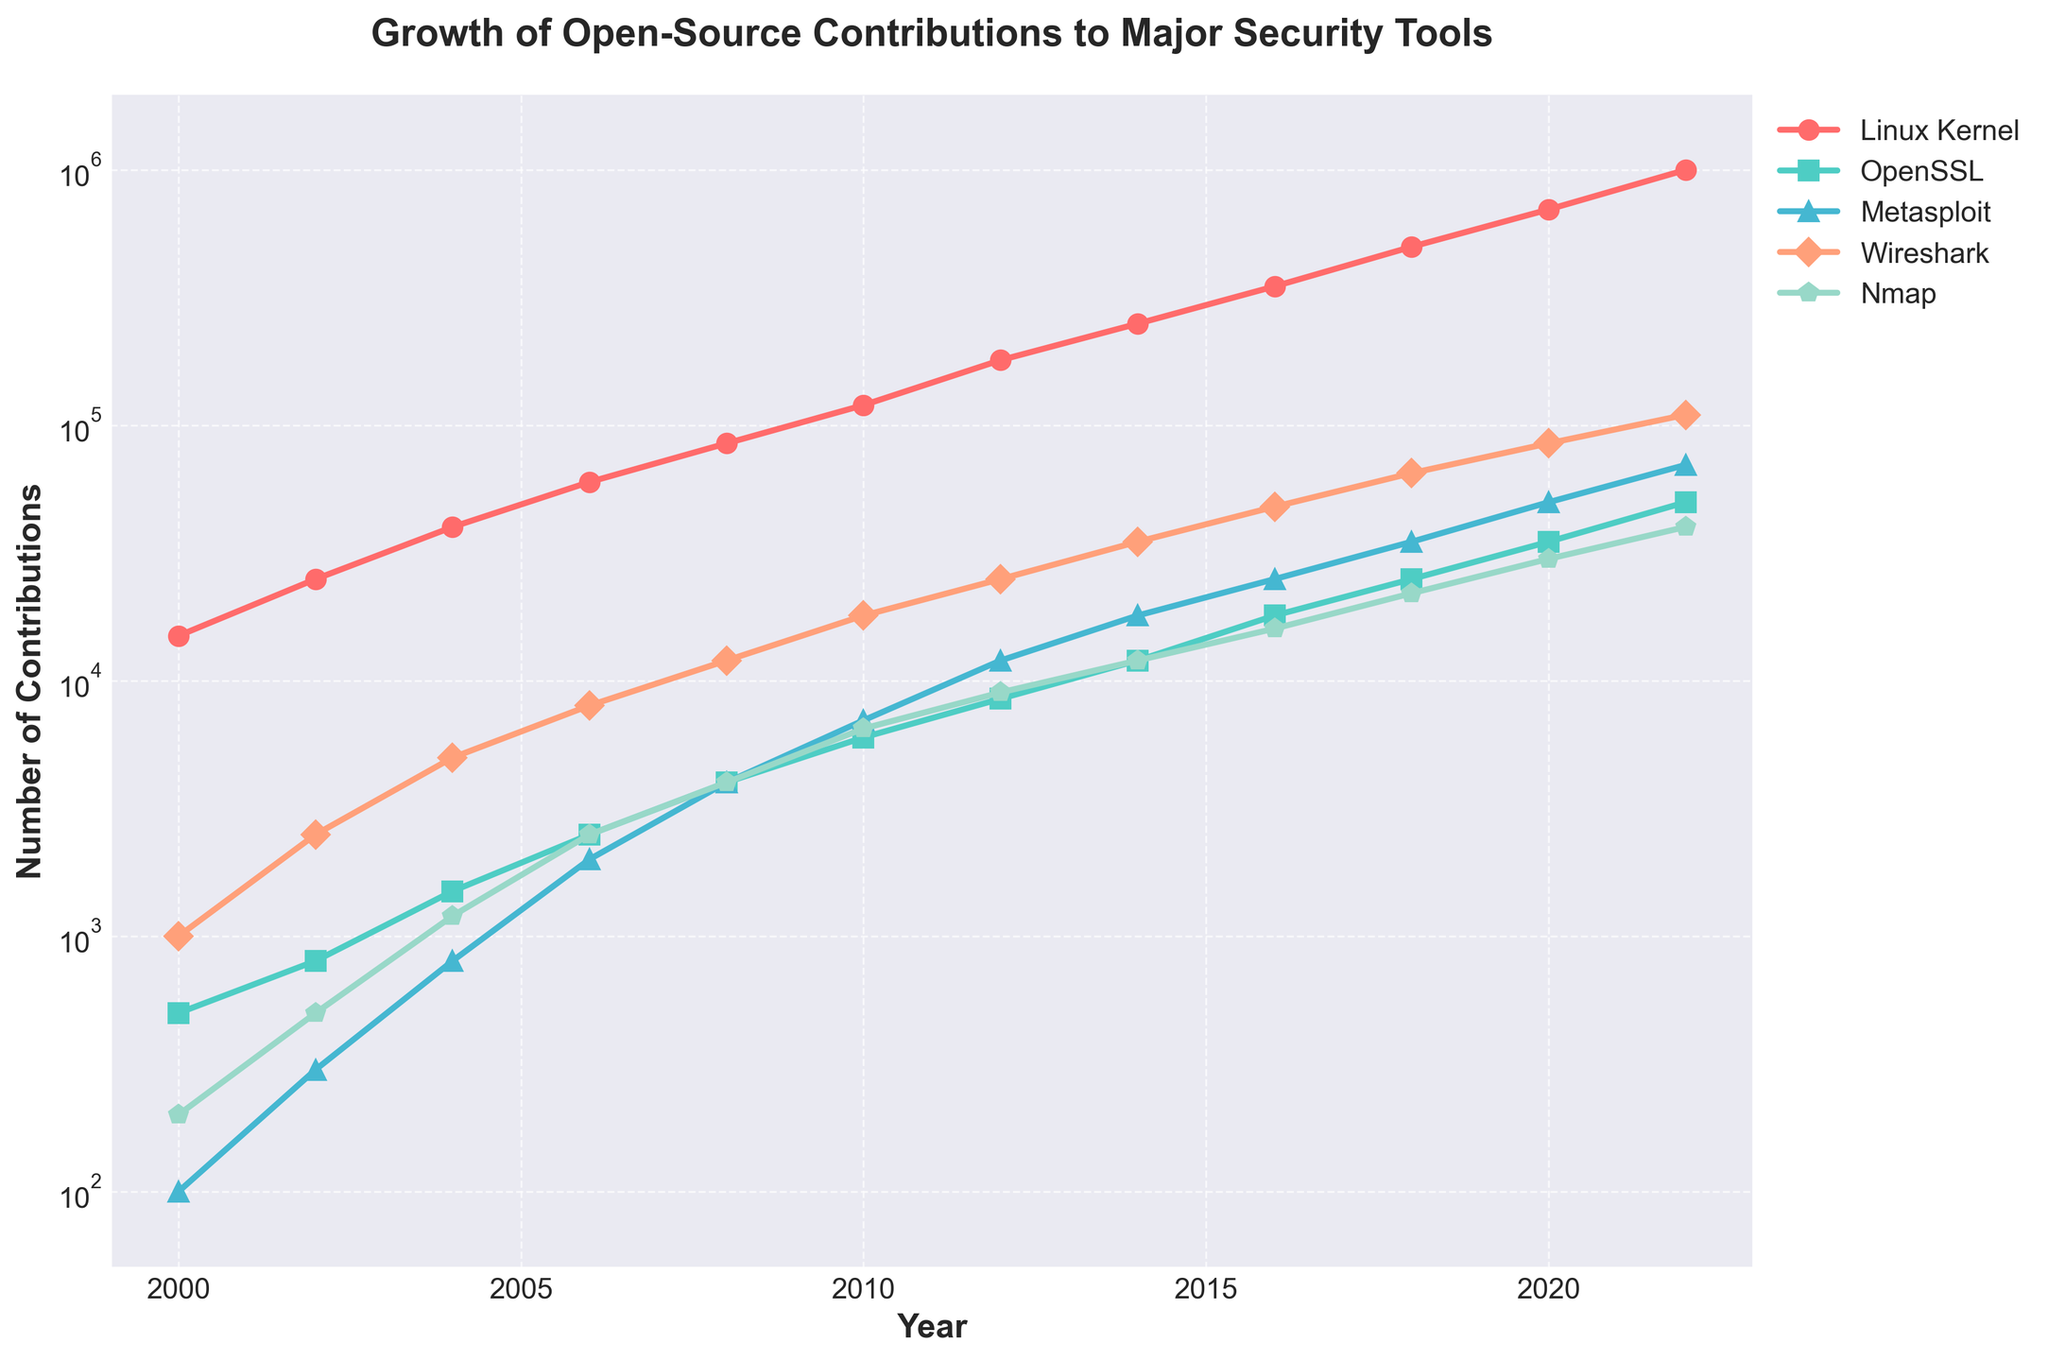which tool had the highest number of contributions in 2012? By examining the plot for the year 2012 and comparing the heights of the lines, it is clear that the Linux Kernel had the highest number of contributions among all tools.
Answer: Linux Kernel how many contributions did Wireshark have in 2016 compared to 2008? In 2016, Wireshark had approximately 48,000 contributions, and in 2008, it had approximately 12,000. Therefore, Wireshark had 48,000 - 12,000 = 36,000 more contributions in 2016 than in 2008.
Answer: 36,000 which tool saw the greatest growth in contributions between 2006 and 2022? To determine which tool saw the greatest growth, compare the differences in contributions between 2006 and 2022 for each tool. Linux Kernel grew from 60,000 to 1,000,000 (940,000), OpenSSL from 2,500 to 50,000 (47,500), Metasploit from 2,000 to 70,000 (68,000), Wireshark from 8,000 to 110,000 (102,000), and Nmap from 2,500 to 40,000 (37,500). Therefore, the Linux Kernel saw the greatest growth.
Answer: Linux Kernel in which year did OpenSSL first surpass 10,000 contributions? By examining the plot and the markers for OpenSSL, the line crosses the 10,000 mark for the first time between 2010 and 2012. Checking the years, 2012 is the first year where the contributions surpass 10,000.
Answer: 2012 how many contributions did Nmap and Metasploit have combined in 2020? According to the chart, in 2020, Nmap had approximately 30,000 contributions and Metasploit had approximately 50,000 contributions. Their combined total is 30,000 + 50,000 = 80,000 contributions.
Answer: 80,000 compare the growth trends of Wireshark and Metasploit between 2010 and 2020. For the specified period, Wireshark grew from 18,000 to 85,000, a difference of 67,000; Metasploit grew from 7,000 to 50,000, a difference of 43,000. Visually inspect the gradients of the lines, Wireshark's trend line shows steeper and more consistent growth compared to Metasploit's.
Answer: Wireshark grew more which tool's contributions appear to have an exponential growth pattern on the plot? By observing the trajectories and noting that the Y-axis is in logarithmic scale, Linux Kernel exhibits an exponential growth pattern more prominently than the other tools. Its curve steepens significantly over time.
Answer: Linux Kernel when did the contributions for Metasploit first exceed 10,000? Observing the line for Metasploit, it crosses the 10,000 mark between 2010 and 2012. Verifying the data points, 2012 is the year Metasploit contributions first surpass 10,000.
Answer: 2012 